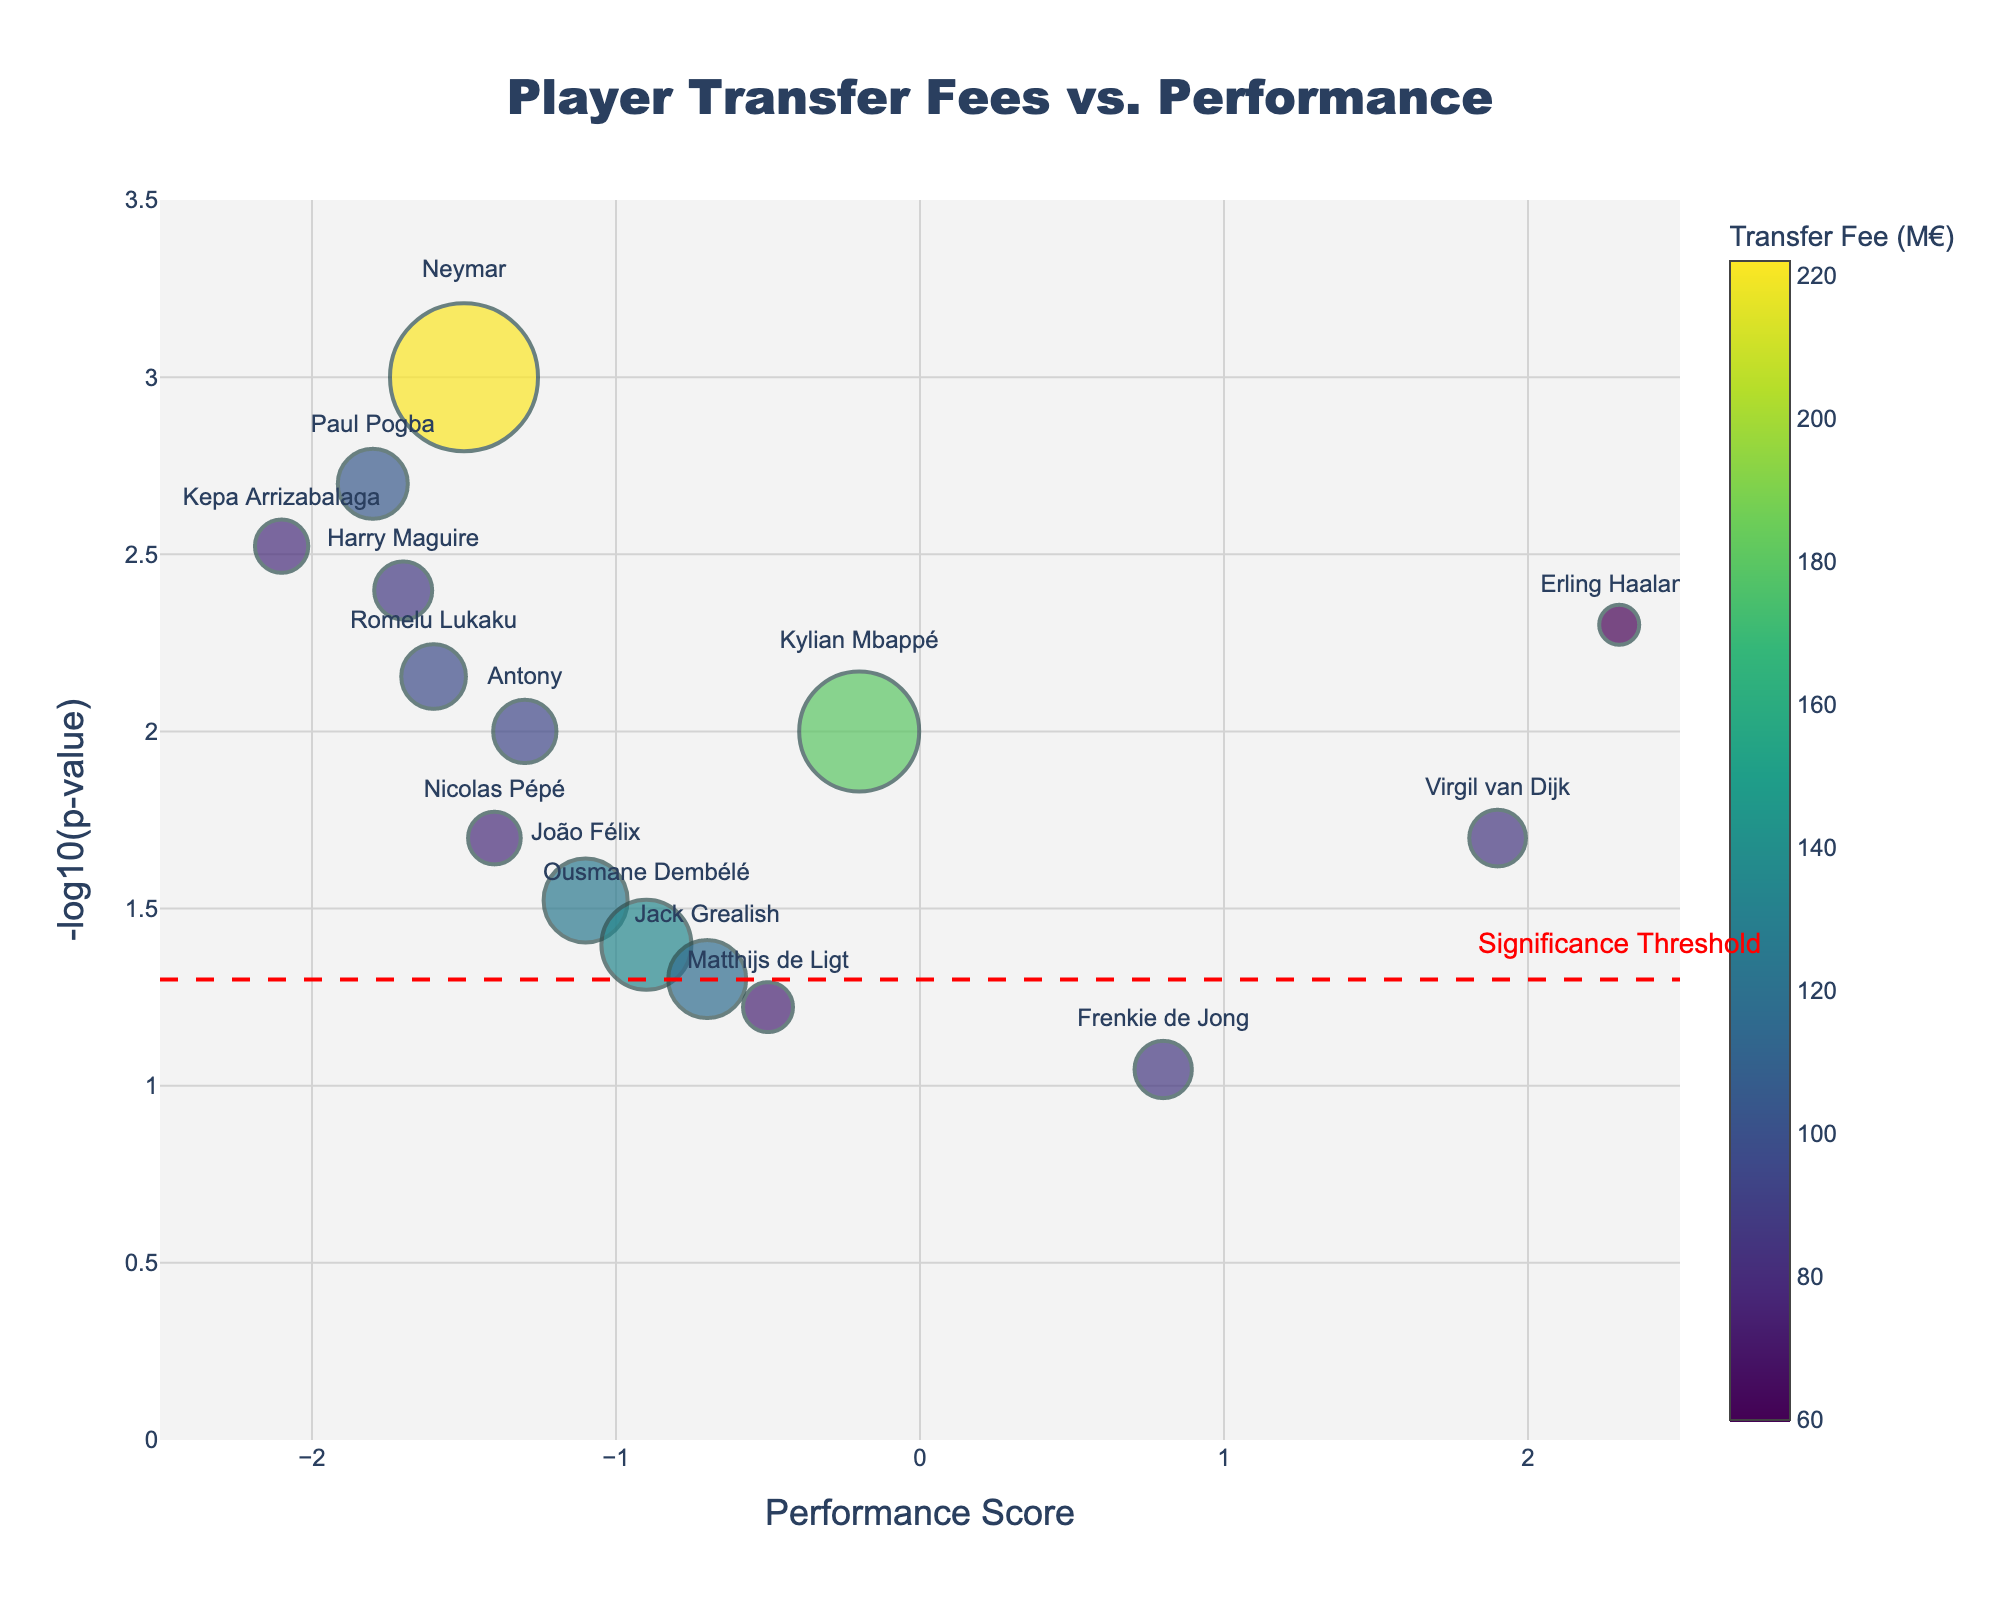What is the title of the figure? The title of the figure is written at the top and centered in the figure. It reads "Player Transfer Fees vs. Performance".
Answer: Player Transfer Fees vs. Performance How many players are represented in the figure? By counting the number of markers in the figure or by looking at the hover text, there are 15 players represented in the figure.
Answer: 15 Who has the highest transfer fee and what is their performance score? From the hover text or marker size, Neymar has the highest transfer fee of 222 million euros. His performance score, as indicated on the x-axis, is -1.5.
Answer: Neymar, -1.5 Which player has the best performance score and what is their p-value? Erling Haaland, identified by his position on the far-right of the x-axis, has the best performance score of 2.3. His p-value is 0.005 as shown in the hover text.
Answer: Erling Haaland, 0.005 Compare the Performance Scores of Kylian Mbappé and Harry Maguire and state who performs better. Kylian Mbappé and Harry Maguire can be identified by their names in the hover text. Kylian Mbappé has a performance score of -0.2, while Harry Maguire has -1.7. Therefore, Kylian Mbappé performs better than Harry Maguire.
Answer: Kylian Mbappé What does the red dashed line in the figure represent? The red dashed line is annotated with the text "Significance Threshold" and is positioned at y = 1.3 on the y-axis. It represents the significance threshold line in the plot.
Answer: Significance Threshold Which player is closest to the significance threshold and what are their transfer fee and performance score? The player closest to the red dashed line (y = 1.3) is Matthijs de Ligt, who has a transfer fee of 75 million euros and a performance score of -0.5.
Answer: Matthijs de Ligt, 75M€, -0.5 How many players have a performance score less than -1.0 and also have a transfer fee above 100 million euros? By examining the x-axis (Performance Score) and marker sizes (Transfer Fees over 100 million euros), three players meet this criterion: Neymar, Paul Pogba, and João Félix.
Answer: 3 Which player has the least significant p-value and what is their performance score? Frenkie de Jong has the least significant p-value of 0.09, as indicated by the smallest y-coordinate value. His performance score, according to the x-axis, is 0.8.
Answer: Frenkie de Jong, 0.8 Which players have a performance score greater than 1.0 and what are their corresponding transfer fees? By looking at the x-axis for values greater than 1.0, the players are Erling Haaland with a transfer fee of 60 million euros and Virgil van Dijk with a transfer fee of 85 million euros.
Answer: Erling Haaland (60M€), Virgil van Dijk (85M€) 